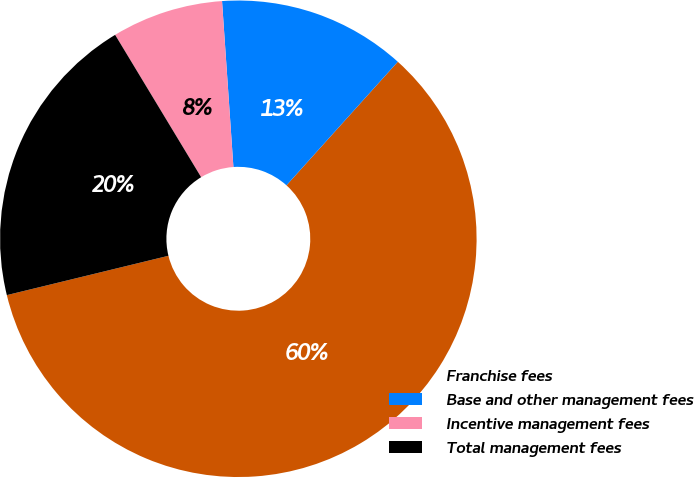<chart> <loc_0><loc_0><loc_500><loc_500><pie_chart><fcel>Franchise fees<fcel>Base and other management fees<fcel>Incentive management fees<fcel>Total management fees<nl><fcel>59.53%<fcel>12.76%<fcel>7.56%<fcel>20.15%<nl></chart> 